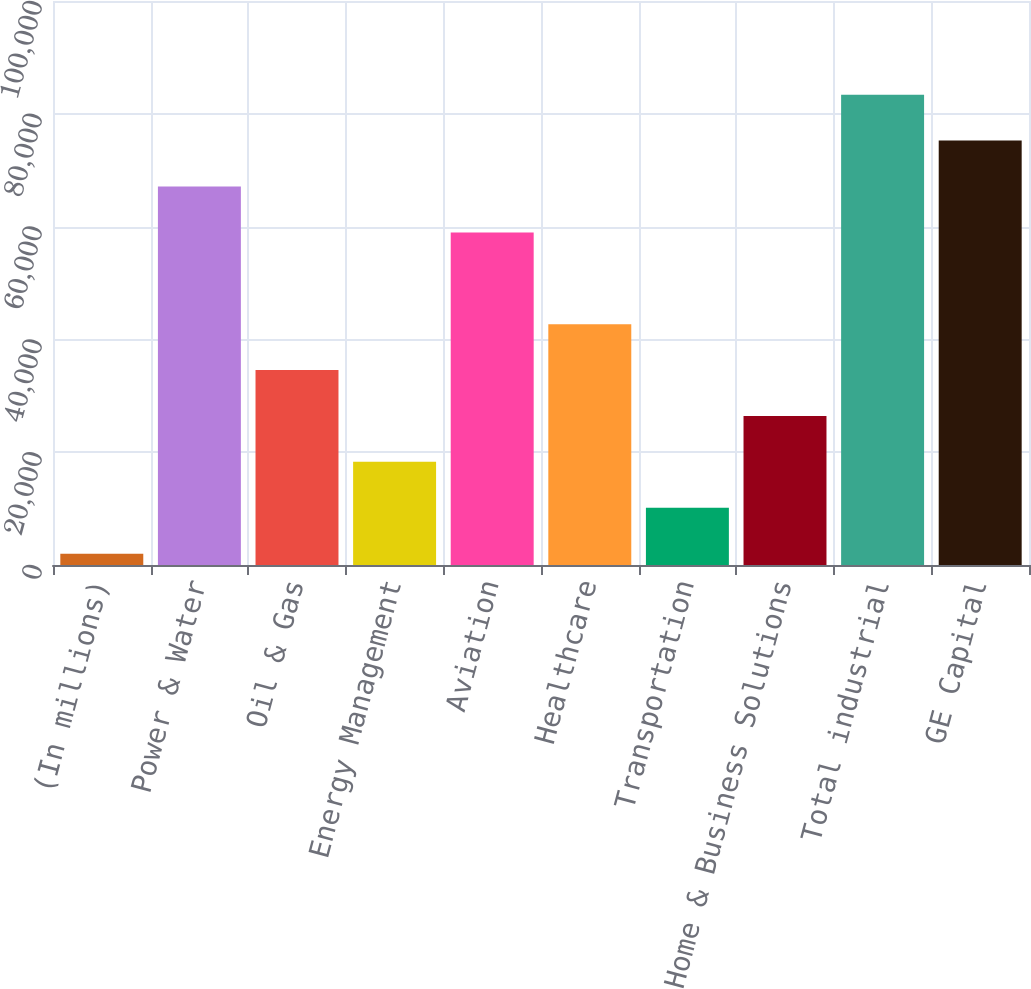Convert chart. <chart><loc_0><loc_0><loc_500><loc_500><bar_chart><fcel>(In millions)<fcel>Power & Water<fcel>Oil & Gas<fcel>Energy Management<fcel>Aviation<fcel>Healthcare<fcel>Transportation<fcel>Home & Business Solutions<fcel>Total industrial<fcel>GE Capital<nl><fcel>2010<fcel>67109.2<fcel>34559.6<fcel>18284.8<fcel>58971.8<fcel>42697<fcel>10147.4<fcel>26422.2<fcel>83384<fcel>75246.6<nl></chart> 